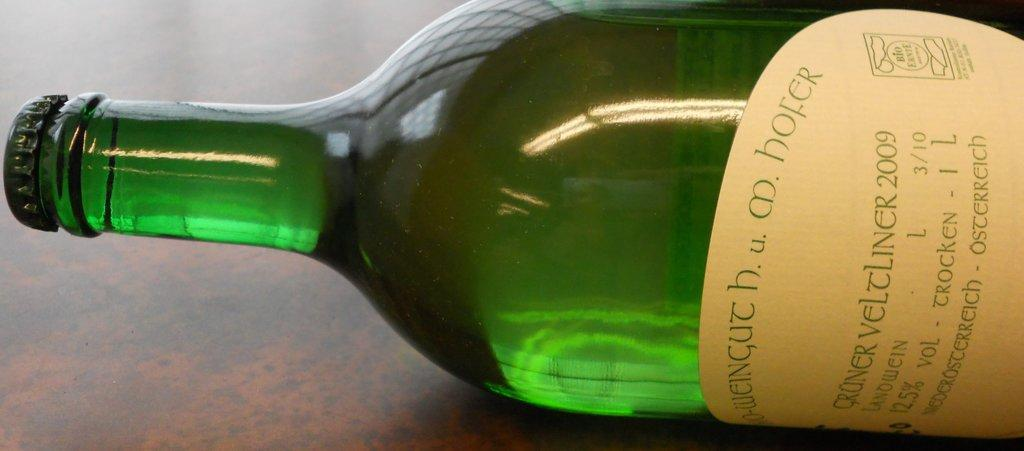<image>
Share a concise interpretation of the image provided. Gruner Veltliner 2009 12.5% alcohol volume 1L bottle of wine with bottlecap laying on its side. 